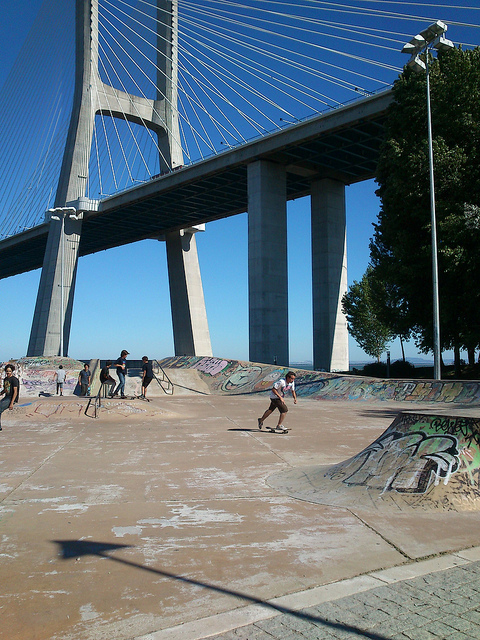<image>What is the name of the bridge? I don't know the name of the bridge. It could be 'Golden Gate' or 'London'. What is the name of the bridge? I don't know the name of the bridge. It can be either Golden Gate or London Bridge. 